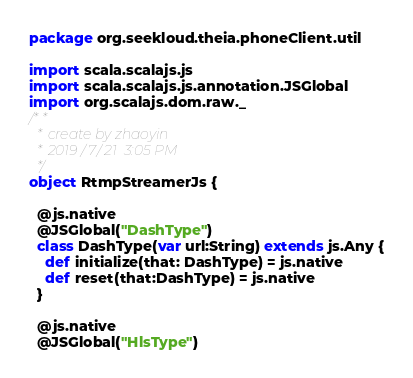<code> <loc_0><loc_0><loc_500><loc_500><_Scala_>package org.seekloud.theia.phoneClient.util

import scala.scalajs.js
import scala.scalajs.js.annotation.JSGlobal
import org.scalajs.dom.raw._
/**
  * create by zhaoyin
  * 2019/7/21  3:05 PM
  */
object RtmpStreamerJs {

  @js.native
  @JSGlobal("DashType")
  class DashType(var url:String) extends js.Any {
    def initialize(that: DashType) = js.native
    def reset(that:DashType) = js.native
  }

  @js.native
  @JSGlobal("HlsType")</code> 